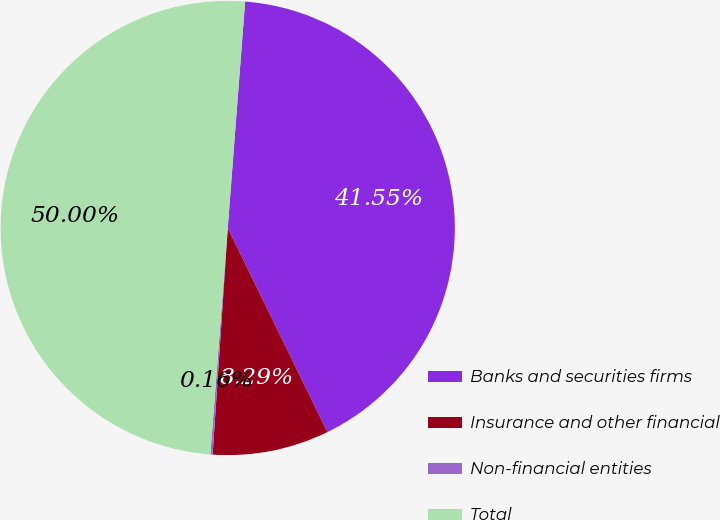Convert chart. <chart><loc_0><loc_0><loc_500><loc_500><pie_chart><fcel>Banks and securities firms<fcel>Insurance and other financial<fcel>Non-financial entities<fcel>Total<nl><fcel>41.55%<fcel>8.29%<fcel>0.16%<fcel>50.0%<nl></chart> 